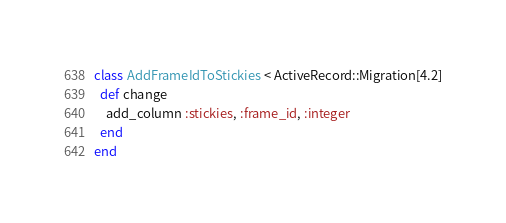<code> <loc_0><loc_0><loc_500><loc_500><_Ruby_>class AddFrameIdToStickies < ActiveRecord::Migration[4.2]
  def change
    add_column :stickies, :frame_id, :integer
  end
end
</code> 